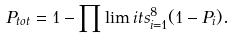Convert formula to latex. <formula><loc_0><loc_0><loc_500><loc_500>P _ { t o t } = 1 - \prod \lim i t s _ { i = 1 } ^ { 8 } ( 1 - P _ { i } ) .</formula> 